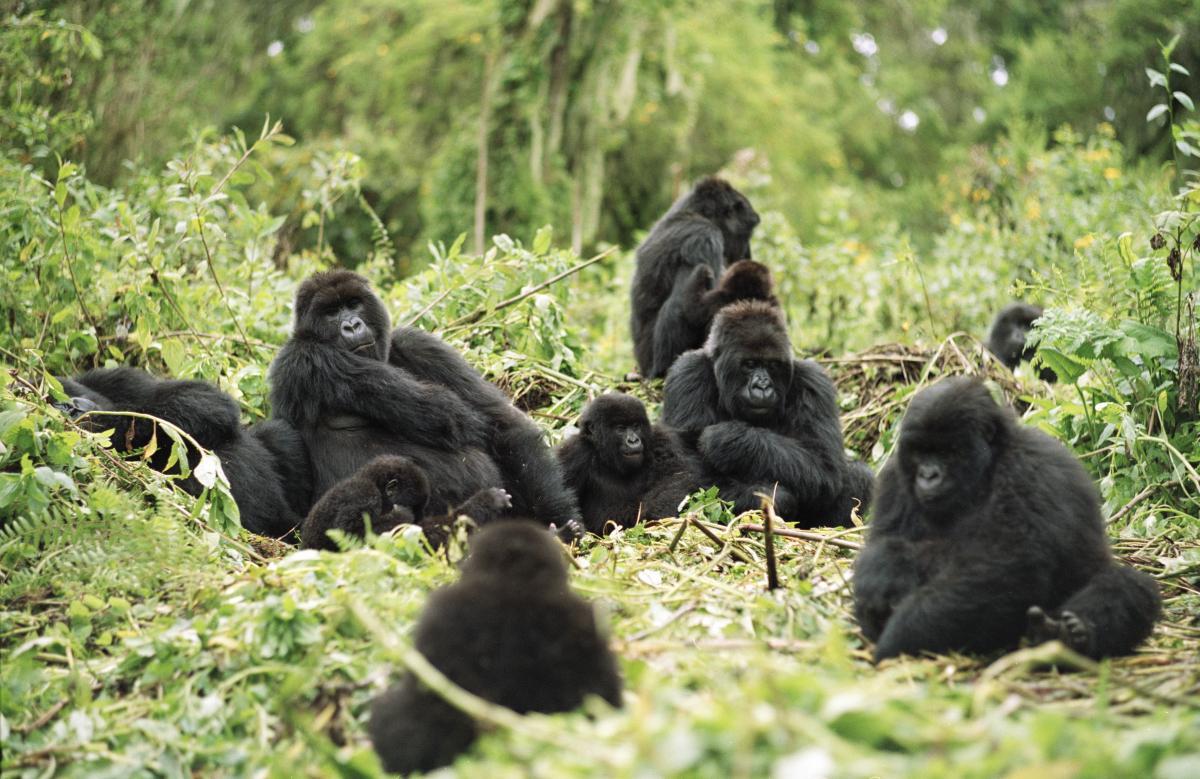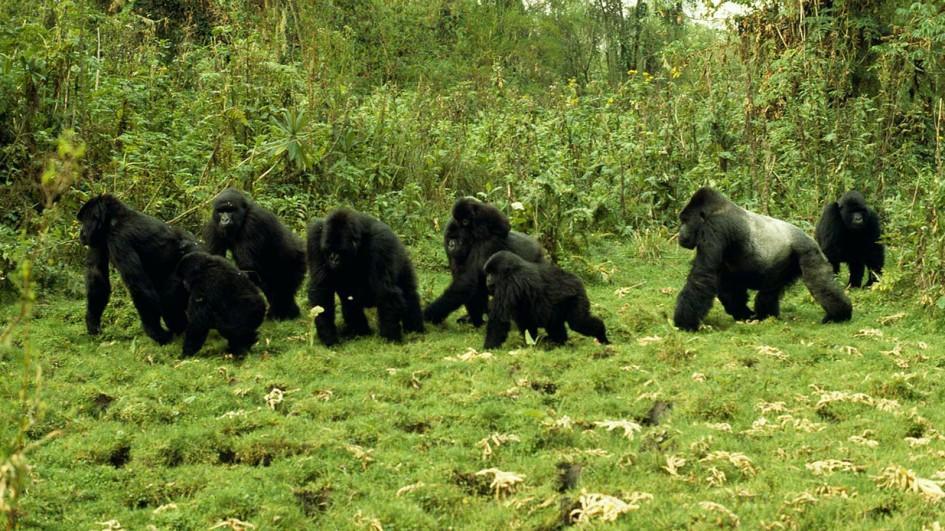The first image is the image on the left, the second image is the image on the right. For the images shown, is this caption "At least one image contains no more than two gorillas and contains at least one adult male." true? Answer yes or no. No. The first image is the image on the left, the second image is the image on the right. Evaluate the accuracy of this statement regarding the images: "There are no more than two gorillas in the right image.". Is it true? Answer yes or no. No. 